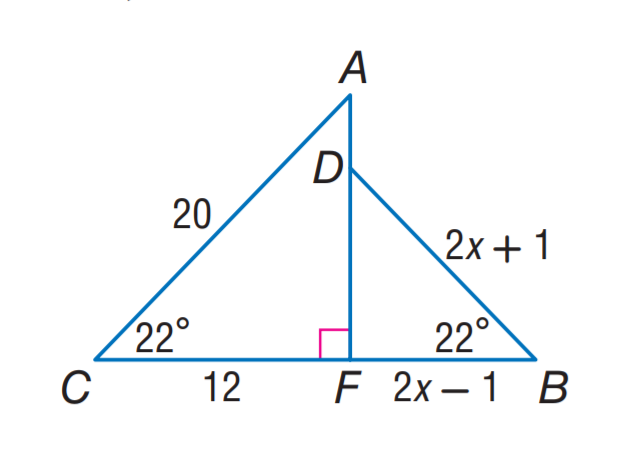Answer the mathemtical geometry problem and directly provide the correct option letter.
Question: Find D B.
Choices: A: 3 B: 5 C: 12 D: 15 B 